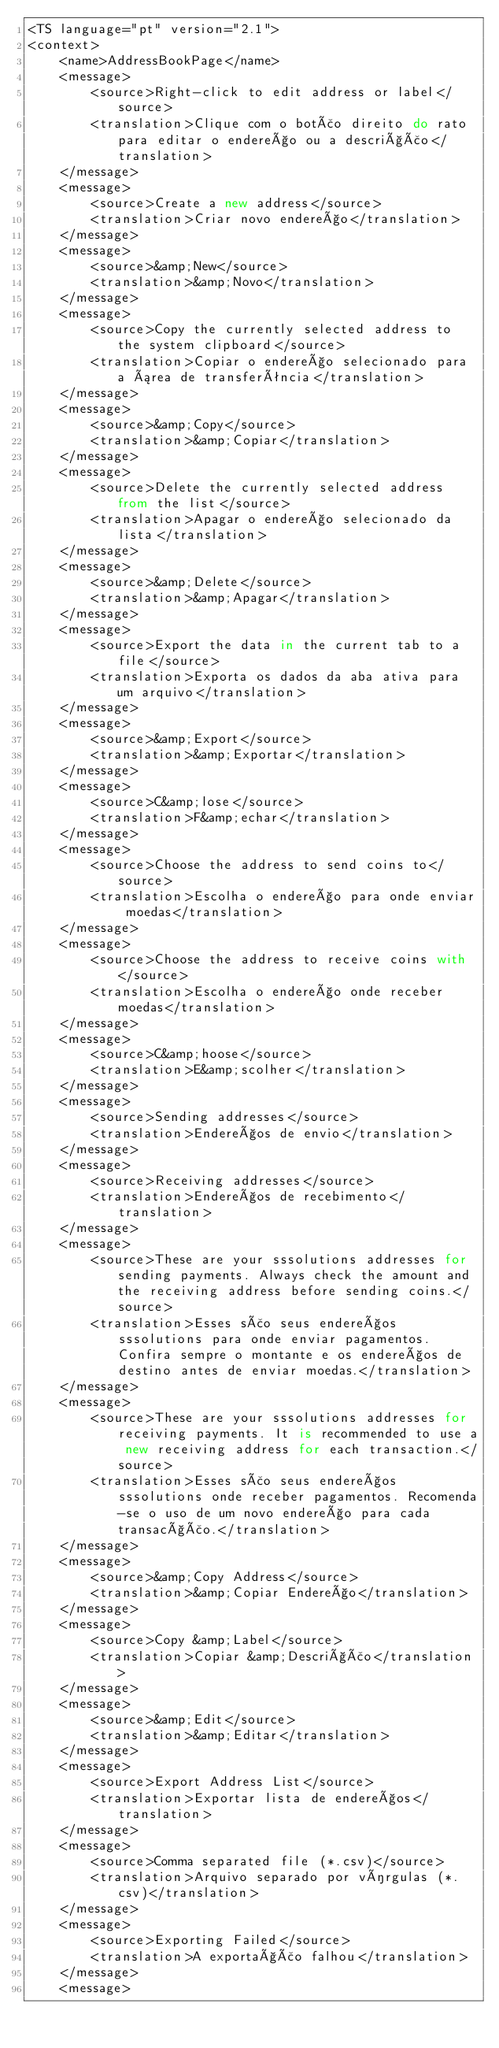Convert code to text. <code><loc_0><loc_0><loc_500><loc_500><_TypeScript_><TS language="pt" version="2.1">
<context>
    <name>AddressBookPage</name>
    <message>
        <source>Right-click to edit address or label</source>
        <translation>Clique com o botão direito do rato para editar o endereço ou a descrição</translation>
    </message>
    <message>
        <source>Create a new address</source>
        <translation>Criar novo endereço</translation>
    </message>
    <message>
        <source>&amp;New</source>
        <translation>&amp;Novo</translation>
    </message>
    <message>
        <source>Copy the currently selected address to the system clipboard</source>
        <translation>Copiar o endereço selecionado para a área de transferência</translation>
    </message>
    <message>
        <source>&amp;Copy</source>
        <translation>&amp;Copiar</translation>
    </message>
    <message>
        <source>Delete the currently selected address from the list</source>
        <translation>Apagar o endereço selecionado da lista</translation>
    </message>
    <message>
        <source>&amp;Delete</source>
        <translation>&amp;Apagar</translation>
    </message>
    <message>
        <source>Export the data in the current tab to a file</source>
        <translation>Exporta os dados da aba ativa para um arquivo</translation>
    </message>
    <message>
        <source>&amp;Export</source>
        <translation>&amp;Exportar</translation>
    </message>
    <message>
        <source>C&amp;lose</source>
        <translation>F&amp;echar</translation>
    </message>
    <message>
        <source>Choose the address to send coins to</source>
        <translation>Escolha o endereço para onde enviar moedas</translation>
    </message>
    <message>
        <source>Choose the address to receive coins with</source>
        <translation>Escolha o endereço onde receber moedas</translation>
    </message>
    <message>
        <source>C&amp;hoose</source>
        <translation>E&amp;scolher</translation>
    </message>
    <message>
        <source>Sending addresses</source>
        <translation>Endereços de envio</translation>
    </message>
    <message>
        <source>Receiving addresses</source>
        <translation>Endereços de recebimento</translation>
    </message>
    <message>
        <source>These are your sssolutions addresses for sending payments. Always check the amount and the receiving address before sending coins.</source>
        <translation>Esses são seus endereços sssolutions para onde enviar pagamentos. Confira sempre o montante e os endereços de destino antes de enviar moedas.</translation>
    </message>
    <message>
        <source>These are your sssolutions addresses for receiving payments. It is recommended to use a new receiving address for each transaction.</source>
        <translation>Esses são seus endereços sssolutions onde receber pagamentos. Recomenda-se o uso de um novo endereço para cada transacção.</translation>
    </message>
    <message>
        <source>&amp;Copy Address</source>
        <translation>&amp;Copiar Endereço</translation>
    </message>
    <message>
        <source>Copy &amp;Label</source>
        <translation>Copiar &amp;Descrição</translation>
    </message>
    <message>
        <source>&amp;Edit</source>
        <translation>&amp;Editar</translation>
    </message>
    <message>
        <source>Export Address List</source>
        <translation>Exportar lista de endereços</translation>
    </message>
    <message>
        <source>Comma separated file (*.csv)</source>
        <translation>Arquivo separado por vírgulas (*.csv)</translation>
    </message>
    <message>
        <source>Exporting Failed</source>
        <translation>A exportação falhou</translation>
    </message>
    <message></code> 